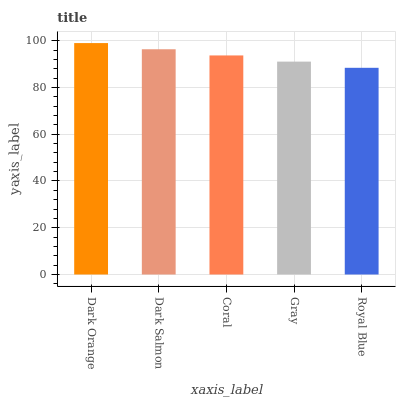Is Royal Blue the minimum?
Answer yes or no. Yes. Is Dark Orange the maximum?
Answer yes or no. Yes. Is Dark Salmon the minimum?
Answer yes or no. No. Is Dark Salmon the maximum?
Answer yes or no. No. Is Dark Orange greater than Dark Salmon?
Answer yes or no. Yes. Is Dark Salmon less than Dark Orange?
Answer yes or no. Yes. Is Dark Salmon greater than Dark Orange?
Answer yes or no. No. Is Dark Orange less than Dark Salmon?
Answer yes or no. No. Is Coral the high median?
Answer yes or no. Yes. Is Coral the low median?
Answer yes or no. Yes. Is Gray the high median?
Answer yes or no. No. Is Dark Orange the low median?
Answer yes or no. No. 